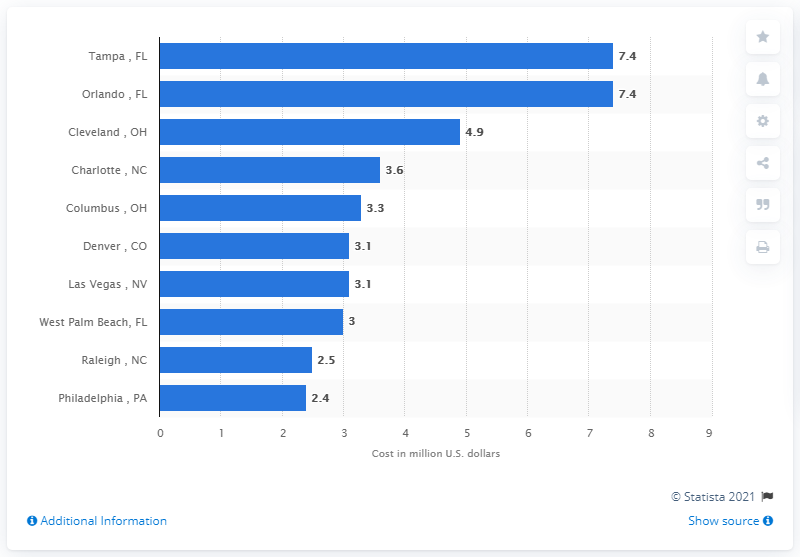Identify some key points in this picture. Approximately 7.4 billion dollars was spent on advertisements for the 2016 US presidential election. 